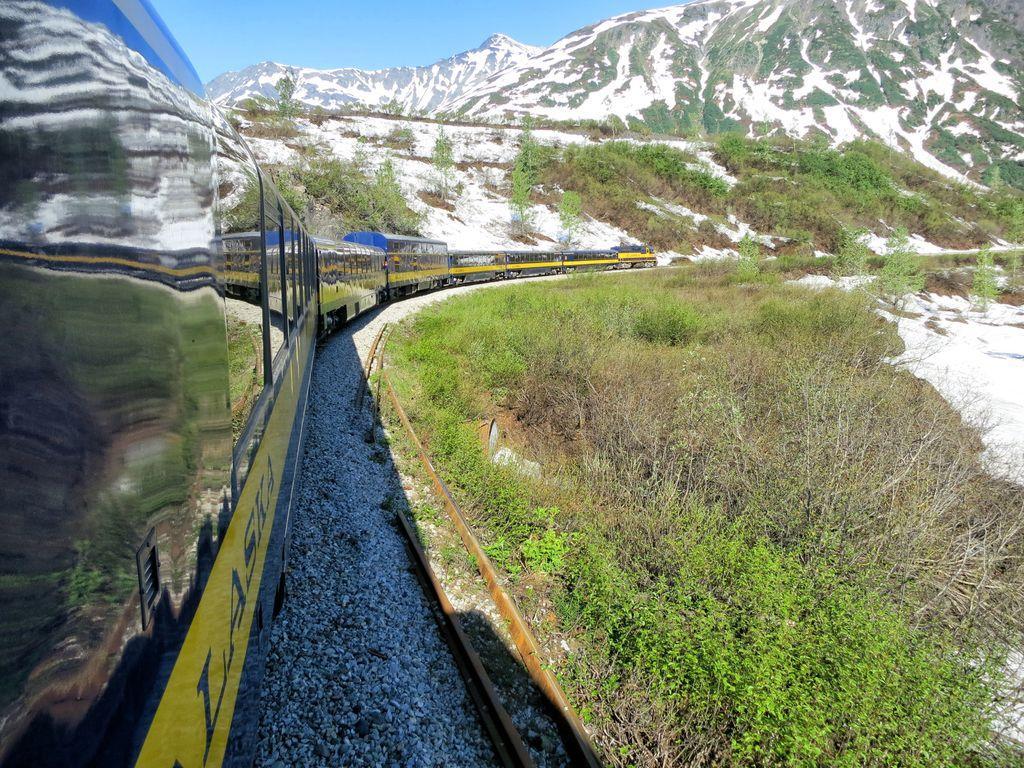Please provide a concise description of this image. In this image there is a train. There is railway track. There are stones. There are trees and grass. There is snow. There are mountains and snow in the background. 